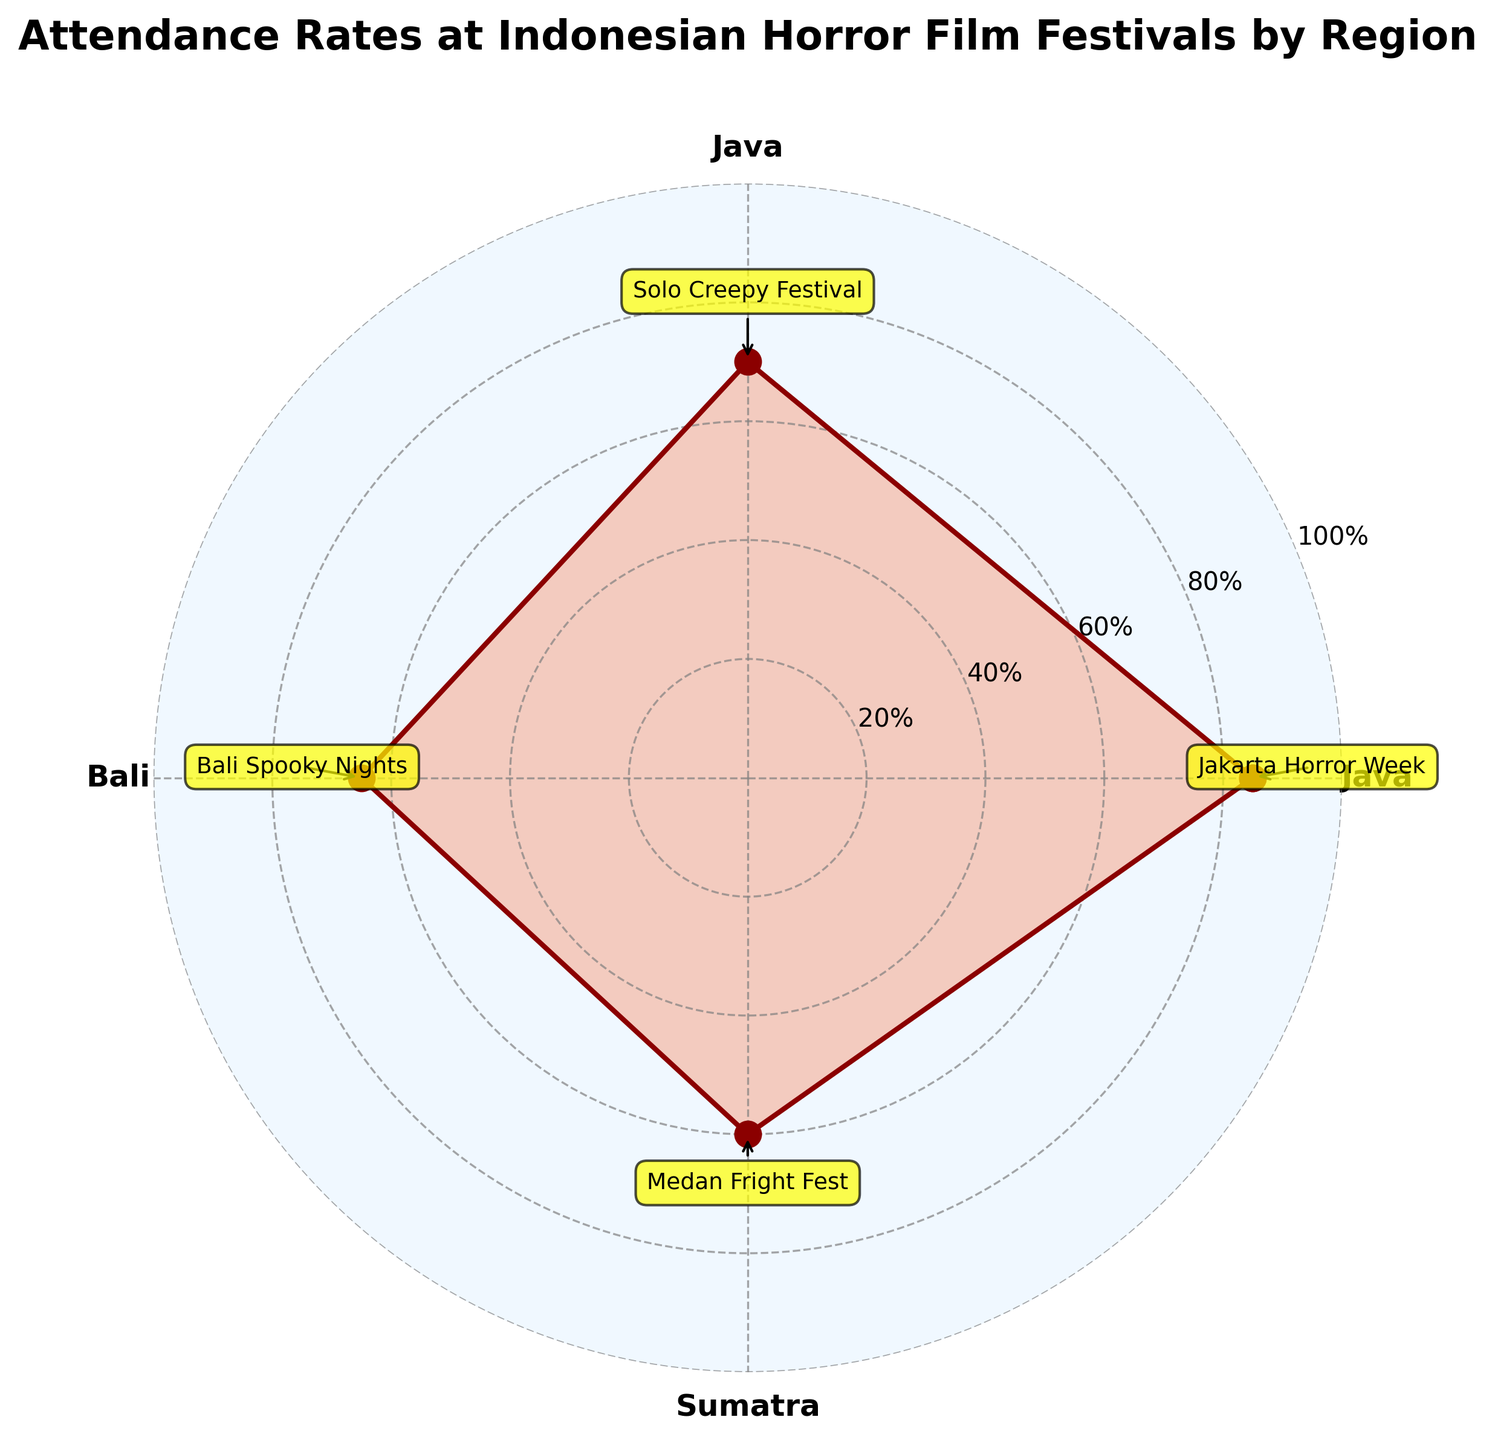What is the main title of the chart? The main title is usually displayed prominently at the top of the chart and provides an overview of what the chart is about.
Answer: Attendance Rates at Indonesian Horror Film Festivals by Region What colors are used in the plot? The chart uses specific colors that can be noticed visually. There is a dark red (#8B0000) for the lines and a lighter orange (#FF4500) for the shaded area.
Answer: Dark red and orange What is the attendance rate for the 'Bali Spooky Nights' event? Look for the 'Bali Spooky Nights' event tag and its corresponding attendance rate, which is plotted as the radius on the polar chart.
Answer: 65% Which region has the highest attendance rate at its horror film festival? Compare the lengths of the radii for each region; the highest one will indicate the highest attendance rate.
Answer: Java How does the attendance rate for 'Jakarta Horror Week' compare to 'Medan Fright Fest'? Look at the radial lengths for both 'Jakarta Horror Week' and 'Medan Fright Fest' and compare them to see which one is greater.
Answer: Jakarta Horror Week has a higher attendance rate What is the average attendance rate among all the regions? Sum up all the attendance rates and divide the total by the number of regions (85+70+65+60)/3.
Answer: 70% Which two events are closest in attendance rate, and what are their rates? Compare the differences in attendance rates between all pairs of events. 'Solo Creepy Festival' and 'Bali Spooky Nights' are closest.
Answer: Solo Creepy Festival (70%) and Bali Spooky Nights (65%) What's the difference in attendance rate between the highest and lowest events? Subtract the smallest attendance rate from the largest attendance rate (85 - 60).
Answer: 25% What do the radial grid's percentage labels represent? The radial grid labels indicate the attendance rates as percentages and help to measure the plotted points against these scales.
Answer: Attendance rates in percentages Which region has the lowest attendance rate? Identify the region with the shortest radial line on the chart.
Answer: Sumatra 